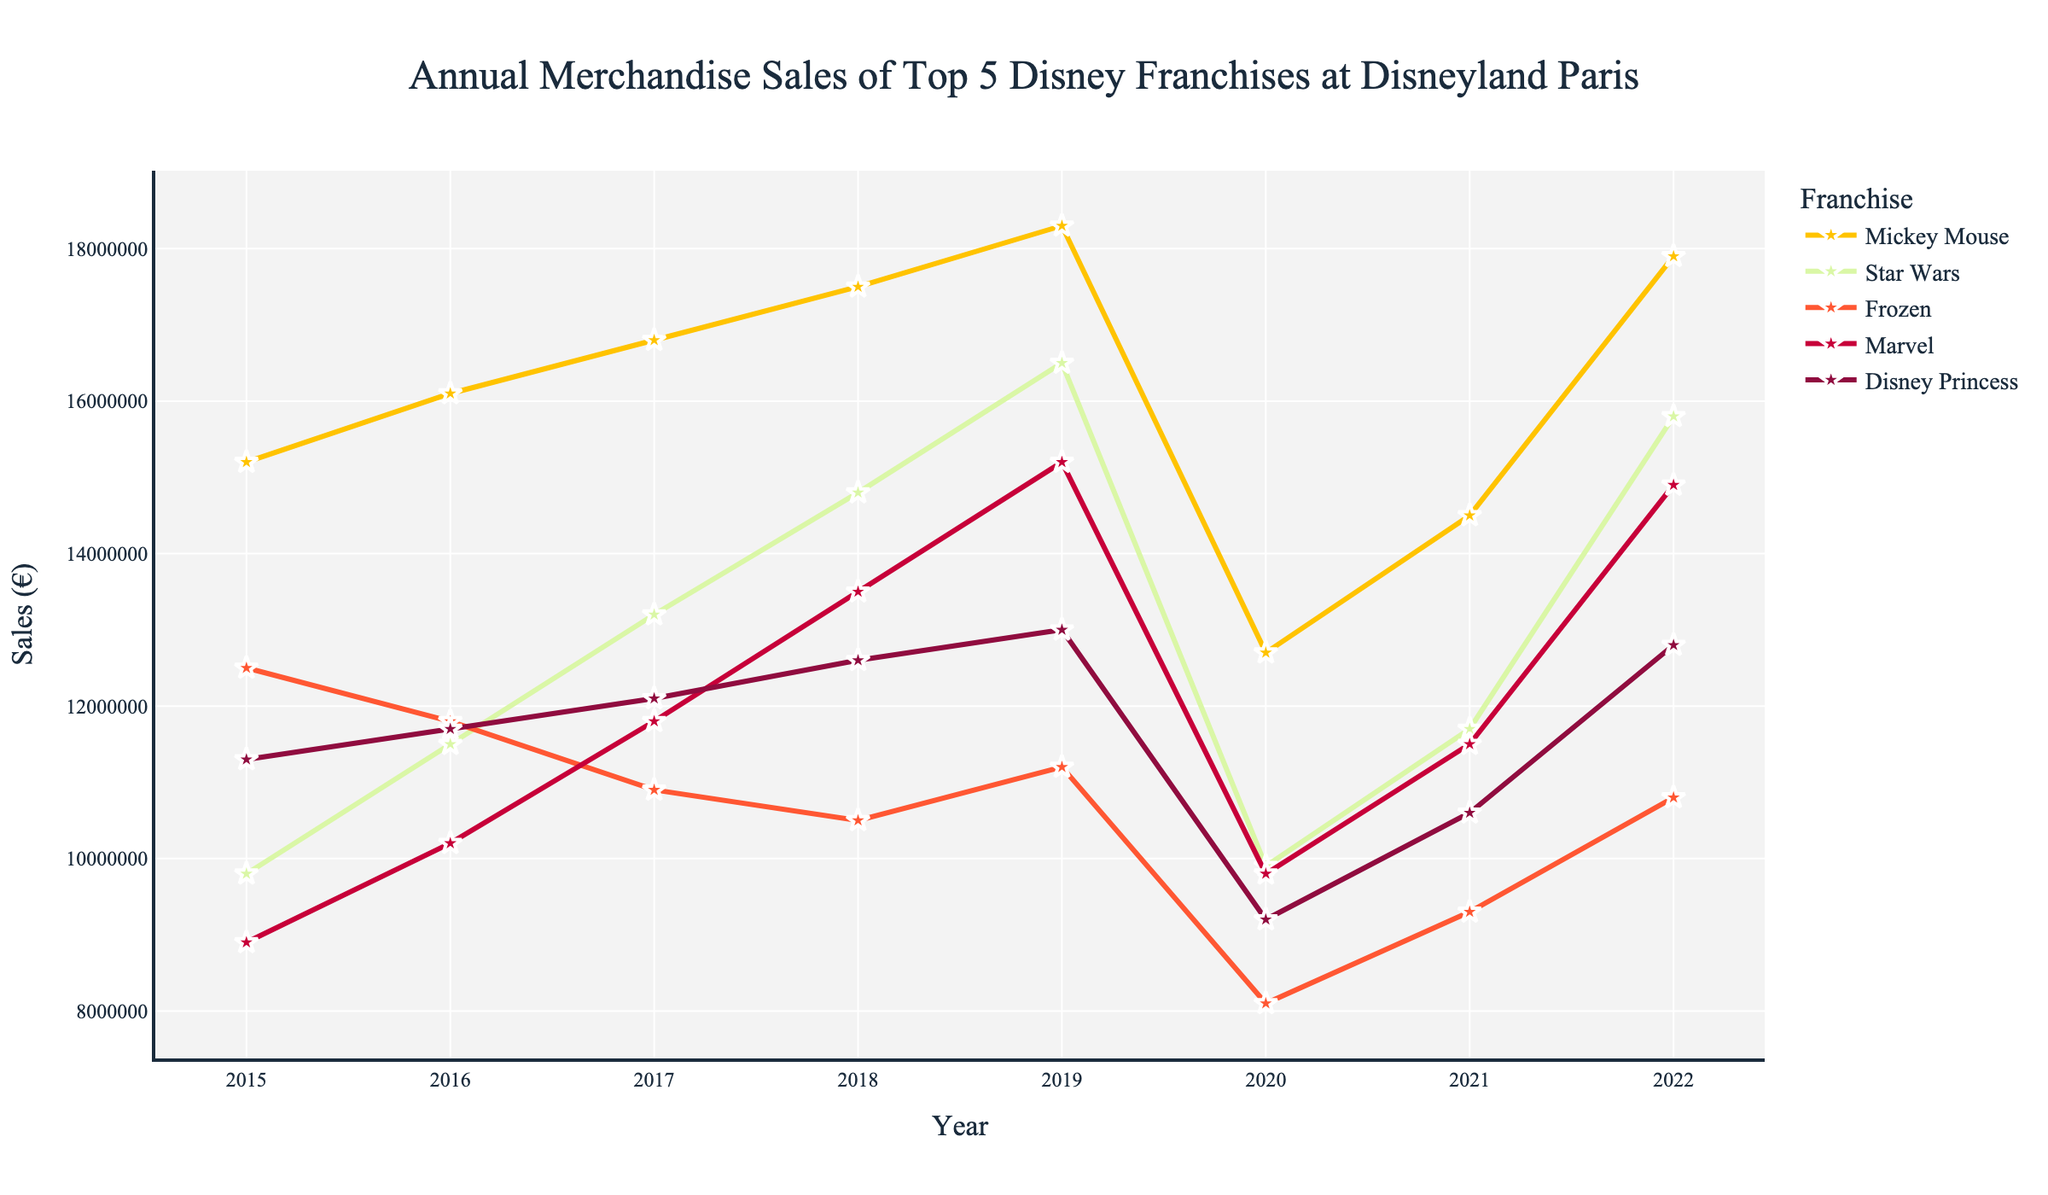What year had the highest sales for Mickey Mouse merchandise? To find the year with the highest sales for Mickey Mouse merchandise, look at the Mickey Mouse line on the graph and identify the peak, which occurs in 2019.
Answer: 2019 Compare the sales of Frozen and Marvel in 2020. Which one had higher sales? In 2020, look at the points on the lines for Frozen and Marvel and compare their heights. Marvel had higher sales with €9.8 million compared to Frozen's €8.1 million.
Answer: Marvel What was the trend in sales for Star Wars from 2015 to 2022? Follow the Star Wars line from 2015 to 2022. Sales increase from 2015 to 2019, drop significantly in 2020, and then rise again in 2021 and 2022 but not reaching the 2019 peak.
Answer: Rising, then falling in 2020, then rising again What is the difference in merchandise sales between Mickey Mouse and Disney Princess in 2022? In 2022, look at the sales figures for both Mickey Mouse (€17.9 million) and Disney Princess (€12.8 million), and subtract the smaller from the larger: €17.9 million - €12.8 million = €5.1 million.
Answer: €5.1 million Calculate the average annual merchandise sales for Frozen from 2015 to 2022. Sum the sales for Frozen from 2015 to 2022 and then divide by the number of years (8). (12.5 + 11.8 + 10.9 + 10.5 + 11.2 + 8.1 + 9.3 + 10.8) million = 85.1 million. 85.1 million / 8 = 10.64 million.
Answer: €10.64 million Which franchise experienced the largest drop in sales between 2019 and 2020? Compare the drop for all franchises between 2019 and 2020. Star Wars dropped from €16.5 million to €9.9 million, which is a drop of €6.6 million, the largest among the franchises.
Answer: Star Wars Identify the year when Marvel sales first surpassed €10 million. Follow the Marvel line and find the first year when it crosses the €10 million mark. This occurred in 2016.
Answer: 2016 How did the sales for Disney Princess merchandise change from 2015 to 2022? Follow the Disney Princess line from 2015 to 2022. Sales increased slightly from 2015 to 2019, dropped in 2020, and then rose again through 2022, ending a bit higher than in 2015.
Answer: Increased, dropped in 2020, then increased again What was the combined sales of Mickey Mouse and Star Wars merchandise in 2015? Sum the sales of Mickey Mouse (€15.2 million) and Star Wars (€9.8 million) in 2015. (€15.2 million + €9.8 million = €25 million).
Answer: €25 million 